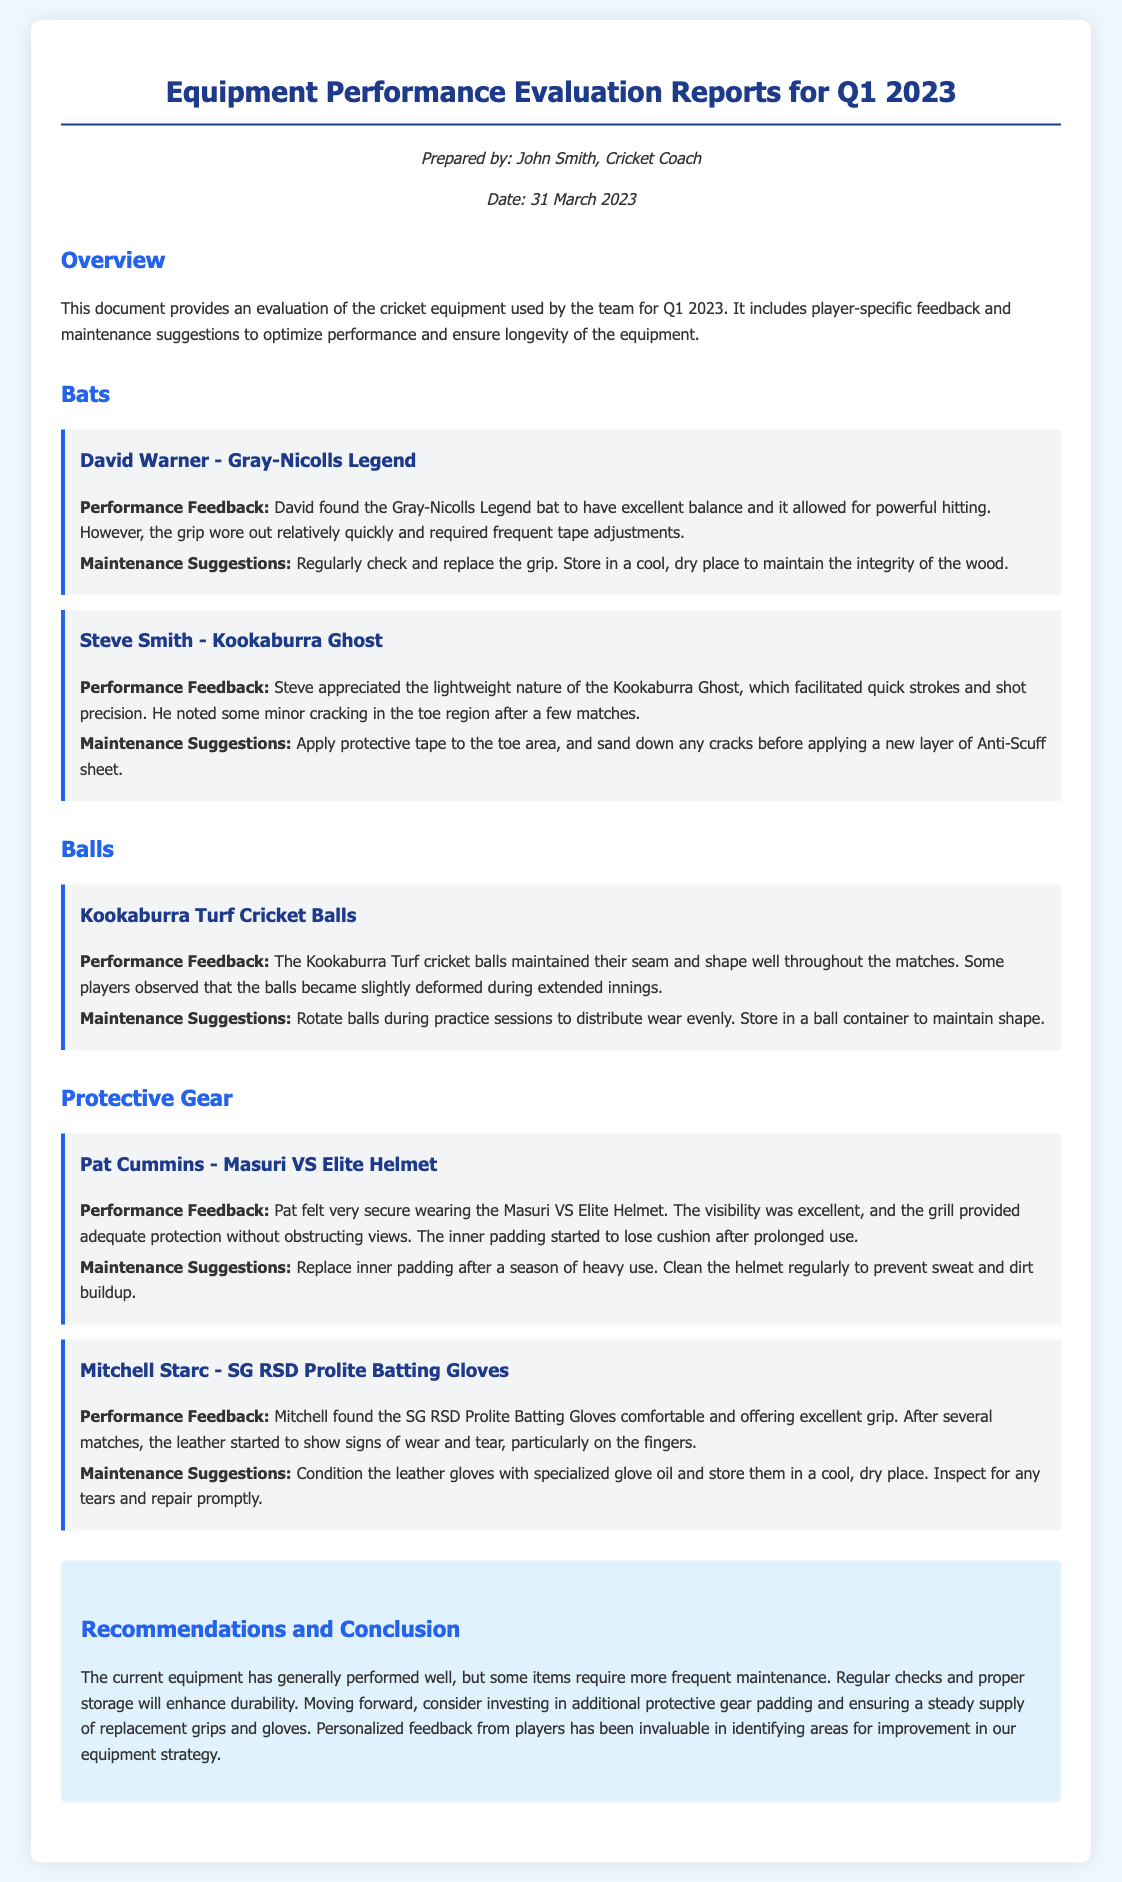What is the title of the document? The title of the document is prominently displayed at the top and is "Equipment Performance Evaluation Reports for Q1 2023."
Answer: Equipment Performance Evaluation Reports for Q1 2023 Who prepared the document? The prepared by section attributes the document to John Smith, which is mentioned in the meta area.
Answer: John Smith What is David Warner's bat model? The item for David Warner lists his bat model as the Gray-Nicolls Legend in the performance feedback section.
Answer: Gray-Nicolls Legend What maintenance suggestion is given for Steve Smith's bat? Ensures that the reader understands the action required for maintenance as suggested in the document for Steve Smith's bat.
Answer: Apply protective tape to the toe area What feedback did players give about the Kookaburra Turf cricket balls? The feedback section for balls indicates that players observed the balls became slightly deformed during extended innings, highlighting a specific issue.
Answer: Slightly deformed What should be done to the inner padding of Pat Cummins' helmet after heavy use? The maintenance suggestions specify replacing the inner padding after a season of heavy use, providing a clear action.
Answer: Replace inner padding What are the recommendations for future equipment improvements? The document has a conclusion section that outlines recommendations for future equipment based on player feedback and maintenance observations.
Answer: Additional protective gear padding How many bats are evaluated in the document? By counting the individual bat feedback sections, one can determine the total count of bats evaluated in the document.
Answer: Two 